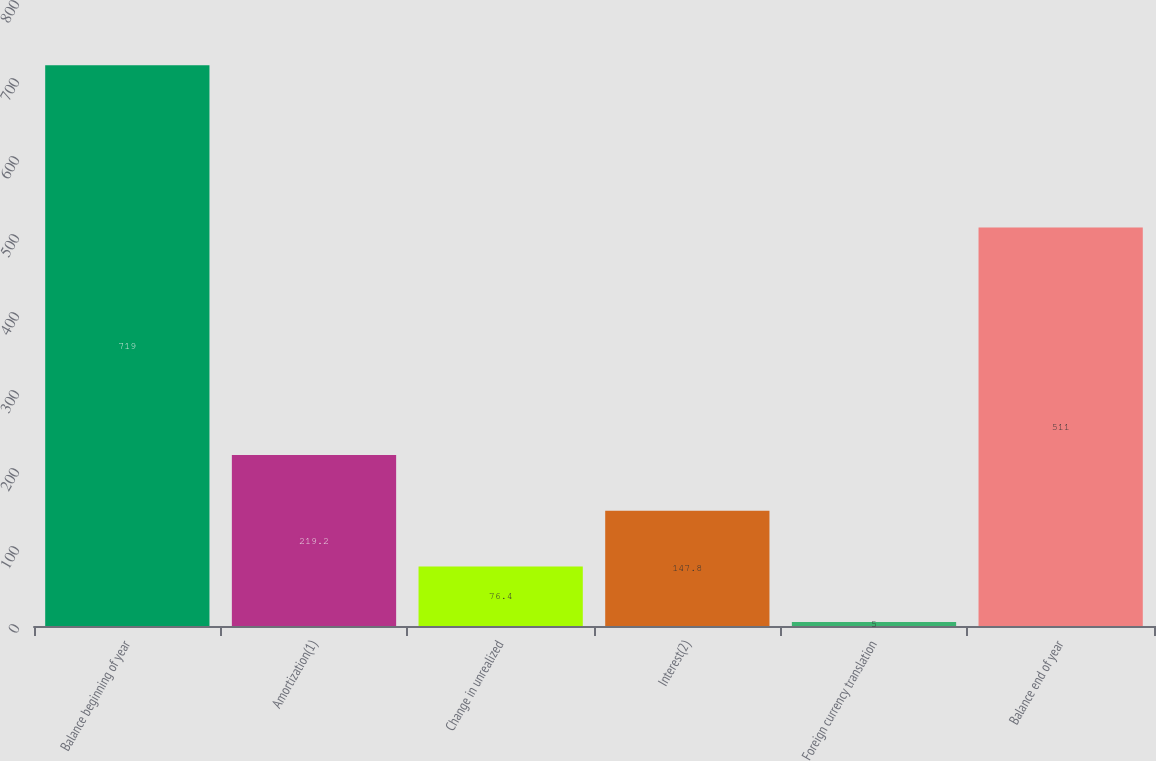<chart> <loc_0><loc_0><loc_500><loc_500><bar_chart><fcel>Balance beginning of year<fcel>Amortization(1)<fcel>Change in unrealized<fcel>Interest(2)<fcel>Foreign currency translation<fcel>Balance end of year<nl><fcel>719<fcel>219.2<fcel>76.4<fcel>147.8<fcel>5<fcel>511<nl></chart> 